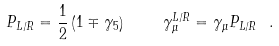Convert formula to latex. <formula><loc_0><loc_0><loc_500><loc_500>P _ { L / R } = \frac { 1 } { 2 } \left ( 1 \mp \gamma _ { 5 } \right ) \quad \gamma _ { \mu } ^ { L / R } = \gamma _ { \mu } P _ { L / R } \ .</formula> 